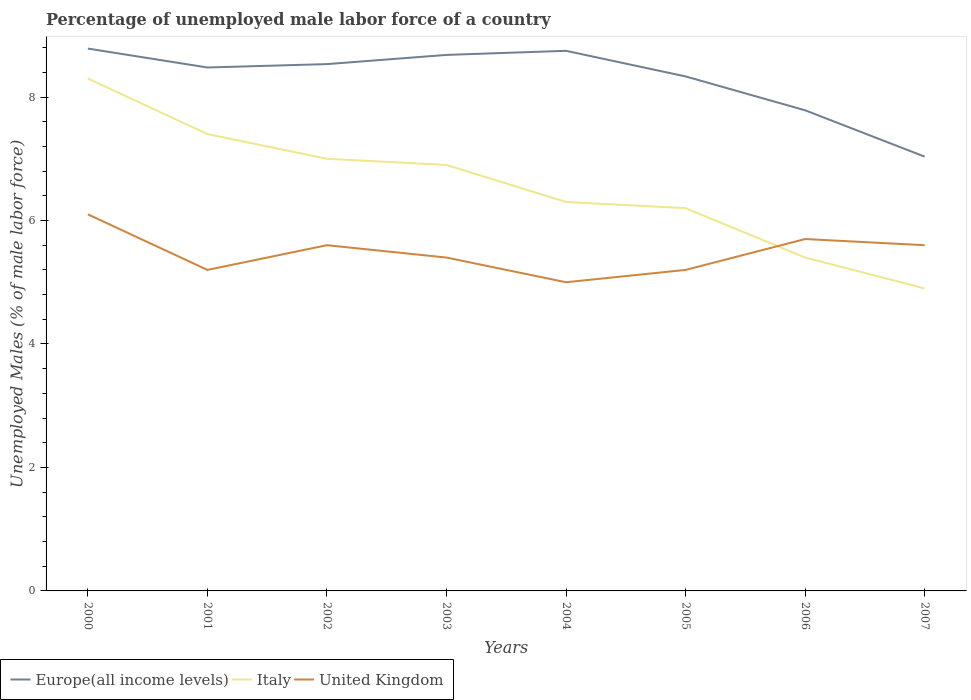What is the total percentage of unemployed male labor force in Europe(all income levels) in the graph?
Your response must be concise. 0.75. What is the difference between the highest and the second highest percentage of unemployed male labor force in Italy?
Your response must be concise. 3.4. How many years are there in the graph?
Offer a terse response. 8. What is the difference between two consecutive major ticks on the Y-axis?
Keep it short and to the point. 2. Does the graph contain any zero values?
Ensure brevity in your answer.  No. What is the title of the graph?
Give a very brief answer. Percentage of unemployed male labor force of a country. What is the label or title of the X-axis?
Ensure brevity in your answer.  Years. What is the label or title of the Y-axis?
Offer a very short reply. Unemployed Males (% of male labor force). What is the Unemployed Males (% of male labor force) in Europe(all income levels) in 2000?
Keep it short and to the point. 8.79. What is the Unemployed Males (% of male labor force) of Italy in 2000?
Your response must be concise. 8.3. What is the Unemployed Males (% of male labor force) of United Kingdom in 2000?
Make the answer very short. 6.1. What is the Unemployed Males (% of male labor force) in Europe(all income levels) in 2001?
Give a very brief answer. 8.48. What is the Unemployed Males (% of male labor force) of Italy in 2001?
Provide a short and direct response. 7.4. What is the Unemployed Males (% of male labor force) in United Kingdom in 2001?
Keep it short and to the point. 5.2. What is the Unemployed Males (% of male labor force) of Europe(all income levels) in 2002?
Offer a very short reply. 8.53. What is the Unemployed Males (% of male labor force) in Italy in 2002?
Your answer should be very brief. 7. What is the Unemployed Males (% of male labor force) in United Kingdom in 2002?
Offer a terse response. 5.6. What is the Unemployed Males (% of male labor force) in Europe(all income levels) in 2003?
Offer a terse response. 8.68. What is the Unemployed Males (% of male labor force) of Italy in 2003?
Ensure brevity in your answer.  6.9. What is the Unemployed Males (% of male labor force) in United Kingdom in 2003?
Offer a very short reply. 5.4. What is the Unemployed Males (% of male labor force) of Europe(all income levels) in 2004?
Offer a very short reply. 8.75. What is the Unemployed Males (% of male labor force) in Italy in 2004?
Offer a terse response. 6.3. What is the Unemployed Males (% of male labor force) of United Kingdom in 2004?
Ensure brevity in your answer.  5. What is the Unemployed Males (% of male labor force) in Europe(all income levels) in 2005?
Give a very brief answer. 8.33. What is the Unemployed Males (% of male labor force) in Italy in 2005?
Provide a succinct answer. 6.2. What is the Unemployed Males (% of male labor force) of United Kingdom in 2005?
Ensure brevity in your answer.  5.2. What is the Unemployed Males (% of male labor force) in Europe(all income levels) in 2006?
Provide a succinct answer. 7.79. What is the Unemployed Males (% of male labor force) of Italy in 2006?
Your answer should be very brief. 5.4. What is the Unemployed Males (% of male labor force) in United Kingdom in 2006?
Make the answer very short. 5.7. What is the Unemployed Males (% of male labor force) of Europe(all income levels) in 2007?
Make the answer very short. 7.03. What is the Unemployed Males (% of male labor force) of Italy in 2007?
Ensure brevity in your answer.  4.9. What is the Unemployed Males (% of male labor force) in United Kingdom in 2007?
Keep it short and to the point. 5.6. Across all years, what is the maximum Unemployed Males (% of male labor force) of Europe(all income levels)?
Offer a terse response. 8.79. Across all years, what is the maximum Unemployed Males (% of male labor force) in Italy?
Offer a terse response. 8.3. Across all years, what is the maximum Unemployed Males (% of male labor force) of United Kingdom?
Your answer should be compact. 6.1. Across all years, what is the minimum Unemployed Males (% of male labor force) in Europe(all income levels)?
Keep it short and to the point. 7.03. Across all years, what is the minimum Unemployed Males (% of male labor force) in Italy?
Make the answer very short. 4.9. What is the total Unemployed Males (% of male labor force) in Europe(all income levels) in the graph?
Make the answer very short. 66.38. What is the total Unemployed Males (% of male labor force) of Italy in the graph?
Offer a very short reply. 52.4. What is the total Unemployed Males (% of male labor force) of United Kingdom in the graph?
Offer a very short reply. 43.8. What is the difference between the Unemployed Males (% of male labor force) in Europe(all income levels) in 2000 and that in 2001?
Your answer should be compact. 0.31. What is the difference between the Unemployed Males (% of male labor force) of Italy in 2000 and that in 2001?
Ensure brevity in your answer.  0.9. What is the difference between the Unemployed Males (% of male labor force) of Europe(all income levels) in 2000 and that in 2002?
Keep it short and to the point. 0.25. What is the difference between the Unemployed Males (% of male labor force) of Italy in 2000 and that in 2002?
Give a very brief answer. 1.3. What is the difference between the Unemployed Males (% of male labor force) of Europe(all income levels) in 2000 and that in 2003?
Keep it short and to the point. 0.1. What is the difference between the Unemployed Males (% of male labor force) of Italy in 2000 and that in 2003?
Offer a terse response. 1.4. What is the difference between the Unemployed Males (% of male labor force) in Europe(all income levels) in 2000 and that in 2004?
Ensure brevity in your answer.  0.04. What is the difference between the Unemployed Males (% of male labor force) of United Kingdom in 2000 and that in 2004?
Your answer should be very brief. 1.1. What is the difference between the Unemployed Males (% of male labor force) of Europe(all income levels) in 2000 and that in 2005?
Make the answer very short. 0.45. What is the difference between the Unemployed Males (% of male labor force) of Italy in 2000 and that in 2005?
Give a very brief answer. 2.1. What is the difference between the Unemployed Males (% of male labor force) of United Kingdom in 2000 and that in 2005?
Give a very brief answer. 0.9. What is the difference between the Unemployed Males (% of male labor force) in Europe(all income levels) in 2000 and that in 2006?
Provide a succinct answer. 1. What is the difference between the Unemployed Males (% of male labor force) in Europe(all income levels) in 2000 and that in 2007?
Give a very brief answer. 1.75. What is the difference between the Unemployed Males (% of male labor force) of United Kingdom in 2000 and that in 2007?
Your response must be concise. 0.5. What is the difference between the Unemployed Males (% of male labor force) of Europe(all income levels) in 2001 and that in 2002?
Your response must be concise. -0.05. What is the difference between the Unemployed Males (% of male labor force) of Italy in 2001 and that in 2002?
Give a very brief answer. 0.4. What is the difference between the Unemployed Males (% of male labor force) of Europe(all income levels) in 2001 and that in 2003?
Your answer should be very brief. -0.2. What is the difference between the Unemployed Males (% of male labor force) in United Kingdom in 2001 and that in 2003?
Keep it short and to the point. -0.2. What is the difference between the Unemployed Males (% of male labor force) of Europe(all income levels) in 2001 and that in 2004?
Your response must be concise. -0.27. What is the difference between the Unemployed Males (% of male labor force) in United Kingdom in 2001 and that in 2004?
Offer a terse response. 0.2. What is the difference between the Unemployed Males (% of male labor force) of Europe(all income levels) in 2001 and that in 2005?
Ensure brevity in your answer.  0.14. What is the difference between the Unemployed Males (% of male labor force) in Italy in 2001 and that in 2005?
Provide a short and direct response. 1.2. What is the difference between the Unemployed Males (% of male labor force) in Europe(all income levels) in 2001 and that in 2006?
Provide a succinct answer. 0.69. What is the difference between the Unemployed Males (% of male labor force) in Italy in 2001 and that in 2006?
Offer a terse response. 2. What is the difference between the Unemployed Males (% of male labor force) of Europe(all income levels) in 2001 and that in 2007?
Give a very brief answer. 1.44. What is the difference between the Unemployed Males (% of male labor force) in Italy in 2001 and that in 2007?
Your answer should be very brief. 2.5. What is the difference between the Unemployed Males (% of male labor force) in United Kingdom in 2001 and that in 2007?
Offer a very short reply. -0.4. What is the difference between the Unemployed Males (% of male labor force) in Europe(all income levels) in 2002 and that in 2003?
Your answer should be very brief. -0.15. What is the difference between the Unemployed Males (% of male labor force) in Italy in 2002 and that in 2003?
Offer a very short reply. 0.1. What is the difference between the Unemployed Males (% of male labor force) of Europe(all income levels) in 2002 and that in 2004?
Keep it short and to the point. -0.22. What is the difference between the Unemployed Males (% of male labor force) of Italy in 2002 and that in 2004?
Your response must be concise. 0.7. What is the difference between the Unemployed Males (% of male labor force) of United Kingdom in 2002 and that in 2004?
Your response must be concise. 0.6. What is the difference between the Unemployed Males (% of male labor force) in Europe(all income levels) in 2002 and that in 2005?
Keep it short and to the point. 0.2. What is the difference between the Unemployed Males (% of male labor force) in Italy in 2002 and that in 2005?
Your response must be concise. 0.8. What is the difference between the Unemployed Males (% of male labor force) in Europe(all income levels) in 2002 and that in 2006?
Ensure brevity in your answer.  0.75. What is the difference between the Unemployed Males (% of male labor force) of United Kingdom in 2002 and that in 2006?
Give a very brief answer. -0.1. What is the difference between the Unemployed Males (% of male labor force) of Europe(all income levels) in 2002 and that in 2007?
Your response must be concise. 1.5. What is the difference between the Unemployed Males (% of male labor force) in United Kingdom in 2002 and that in 2007?
Offer a terse response. 0. What is the difference between the Unemployed Males (% of male labor force) of Europe(all income levels) in 2003 and that in 2004?
Ensure brevity in your answer.  -0.07. What is the difference between the Unemployed Males (% of male labor force) in Europe(all income levels) in 2003 and that in 2005?
Offer a very short reply. 0.35. What is the difference between the Unemployed Males (% of male labor force) of United Kingdom in 2003 and that in 2005?
Your answer should be very brief. 0.2. What is the difference between the Unemployed Males (% of male labor force) of Europe(all income levels) in 2003 and that in 2006?
Make the answer very short. 0.9. What is the difference between the Unemployed Males (% of male labor force) of Europe(all income levels) in 2003 and that in 2007?
Provide a short and direct response. 1.65. What is the difference between the Unemployed Males (% of male labor force) in Italy in 2003 and that in 2007?
Offer a terse response. 2. What is the difference between the Unemployed Males (% of male labor force) in United Kingdom in 2003 and that in 2007?
Make the answer very short. -0.2. What is the difference between the Unemployed Males (% of male labor force) of Europe(all income levels) in 2004 and that in 2005?
Your answer should be compact. 0.41. What is the difference between the Unemployed Males (% of male labor force) in Italy in 2004 and that in 2005?
Provide a short and direct response. 0.1. What is the difference between the Unemployed Males (% of male labor force) in United Kingdom in 2004 and that in 2005?
Provide a short and direct response. -0.2. What is the difference between the Unemployed Males (% of male labor force) in Europe(all income levels) in 2004 and that in 2006?
Your response must be concise. 0.96. What is the difference between the Unemployed Males (% of male labor force) of Italy in 2004 and that in 2006?
Your answer should be compact. 0.9. What is the difference between the Unemployed Males (% of male labor force) in Europe(all income levels) in 2004 and that in 2007?
Make the answer very short. 1.71. What is the difference between the Unemployed Males (% of male labor force) of Europe(all income levels) in 2005 and that in 2006?
Ensure brevity in your answer.  0.55. What is the difference between the Unemployed Males (% of male labor force) of Italy in 2005 and that in 2006?
Make the answer very short. 0.8. What is the difference between the Unemployed Males (% of male labor force) in United Kingdom in 2005 and that in 2006?
Your answer should be compact. -0.5. What is the difference between the Unemployed Males (% of male labor force) in Europe(all income levels) in 2005 and that in 2007?
Offer a terse response. 1.3. What is the difference between the Unemployed Males (% of male labor force) of Italy in 2005 and that in 2007?
Provide a short and direct response. 1.3. What is the difference between the Unemployed Males (% of male labor force) of Europe(all income levels) in 2006 and that in 2007?
Ensure brevity in your answer.  0.75. What is the difference between the Unemployed Males (% of male labor force) in Italy in 2006 and that in 2007?
Your answer should be compact. 0.5. What is the difference between the Unemployed Males (% of male labor force) of Europe(all income levels) in 2000 and the Unemployed Males (% of male labor force) of Italy in 2001?
Provide a succinct answer. 1.39. What is the difference between the Unemployed Males (% of male labor force) in Europe(all income levels) in 2000 and the Unemployed Males (% of male labor force) in United Kingdom in 2001?
Provide a succinct answer. 3.59. What is the difference between the Unemployed Males (% of male labor force) of Europe(all income levels) in 2000 and the Unemployed Males (% of male labor force) of Italy in 2002?
Make the answer very short. 1.79. What is the difference between the Unemployed Males (% of male labor force) of Europe(all income levels) in 2000 and the Unemployed Males (% of male labor force) of United Kingdom in 2002?
Offer a terse response. 3.19. What is the difference between the Unemployed Males (% of male labor force) in Italy in 2000 and the Unemployed Males (% of male labor force) in United Kingdom in 2002?
Keep it short and to the point. 2.7. What is the difference between the Unemployed Males (% of male labor force) of Europe(all income levels) in 2000 and the Unemployed Males (% of male labor force) of Italy in 2003?
Your response must be concise. 1.89. What is the difference between the Unemployed Males (% of male labor force) of Europe(all income levels) in 2000 and the Unemployed Males (% of male labor force) of United Kingdom in 2003?
Offer a very short reply. 3.39. What is the difference between the Unemployed Males (% of male labor force) in Italy in 2000 and the Unemployed Males (% of male labor force) in United Kingdom in 2003?
Keep it short and to the point. 2.9. What is the difference between the Unemployed Males (% of male labor force) in Europe(all income levels) in 2000 and the Unemployed Males (% of male labor force) in Italy in 2004?
Your answer should be compact. 2.49. What is the difference between the Unemployed Males (% of male labor force) of Europe(all income levels) in 2000 and the Unemployed Males (% of male labor force) of United Kingdom in 2004?
Ensure brevity in your answer.  3.79. What is the difference between the Unemployed Males (% of male labor force) of Europe(all income levels) in 2000 and the Unemployed Males (% of male labor force) of Italy in 2005?
Your response must be concise. 2.59. What is the difference between the Unemployed Males (% of male labor force) in Europe(all income levels) in 2000 and the Unemployed Males (% of male labor force) in United Kingdom in 2005?
Your response must be concise. 3.59. What is the difference between the Unemployed Males (% of male labor force) of Europe(all income levels) in 2000 and the Unemployed Males (% of male labor force) of Italy in 2006?
Keep it short and to the point. 3.39. What is the difference between the Unemployed Males (% of male labor force) of Europe(all income levels) in 2000 and the Unemployed Males (% of male labor force) of United Kingdom in 2006?
Make the answer very short. 3.09. What is the difference between the Unemployed Males (% of male labor force) of Italy in 2000 and the Unemployed Males (% of male labor force) of United Kingdom in 2006?
Provide a succinct answer. 2.6. What is the difference between the Unemployed Males (% of male labor force) of Europe(all income levels) in 2000 and the Unemployed Males (% of male labor force) of Italy in 2007?
Ensure brevity in your answer.  3.89. What is the difference between the Unemployed Males (% of male labor force) in Europe(all income levels) in 2000 and the Unemployed Males (% of male labor force) in United Kingdom in 2007?
Give a very brief answer. 3.19. What is the difference between the Unemployed Males (% of male labor force) in Europe(all income levels) in 2001 and the Unemployed Males (% of male labor force) in Italy in 2002?
Offer a very short reply. 1.48. What is the difference between the Unemployed Males (% of male labor force) in Europe(all income levels) in 2001 and the Unemployed Males (% of male labor force) in United Kingdom in 2002?
Give a very brief answer. 2.88. What is the difference between the Unemployed Males (% of male labor force) of Italy in 2001 and the Unemployed Males (% of male labor force) of United Kingdom in 2002?
Ensure brevity in your answer.  1.8. What is the difference between the Unemployed Males (% of male labor force) of Europe(all income levels) in 2001 and the Unemployed Males (% of male labor force) of Italy in 2003?
Ensure brevity in your answer.  1.58. What is the difference between the Unemployed Males (% of male labor force) in Europe(all income levels) in 2001 and the Unemployed Males (% of male labor force) in United Kingdom in 2003?
Provide a succinct answer. 3.08. What is the difference between the Unemployed Males (% of male labor force) of Italy in 2001 and the Unemployed Males (% of male labor force) of United Kingdom in 2003?
Offer a terse response. 2. What is the difference between the Unemployed Males (% of male labor force) in Europe(all income levels) in 2001 and the Unemployed Males (% of male labor force) in Italy in 2004?
Your response must be concise. 2.18. What is the difference between the Unemployed Males (% of male labor force) of Europe(all income levels) in 2001 and the Unemployed Males (% of male labor force) of United Kingdom in 2004?
Offer a terse response. 3.48. What is the difference between the Unemployed Males (% of male labor force) in Europe(all income levels) in 2001 and the Unemployed Males (% of male labor force) in Italy in 2005?
Keep it short and to the point. 2.28. What is the difference between the Unemployed Males (% of male labor force) of Europe(all income levels) in 2001 and the Unemployed Males (% of male labor force) of United Kingdom in 2005?
Ensure brevity in your answer.  3.28. What is the difference between the Unemployed Males (% of male labor force) in Europe(all income levels) in 2001 and the Unemployed Males (% of male labor force) in Italy in 2006?
Your answer should be very brief. 3.08. What is the difference between the Unemployed Males (% of male labor force) in Europe(all income levels) in 2001 and the Unemployed Males (% of male labor force) in United Kingdom in 2006?
Your answer should be very brief. 2.78. What is the difference between the Unemployed Males (% of male labor force) of Europe(all income levels) in 2001 and the Unemployed Males (% of male labor force) of Italy in 2007?
Make the answer very short. 3.58. What is the difference between the Unemployed Males (% of male labor force) in Europe(all income levels) in 2001 and the Unemployed Males (% of male labor force) in United Kingdom in 2007?
Offer a terse response. 2.88. What is the difference between the Unemployed Males (% of male labor force) in Europe(all income levels) in 2002 and the Unemployed Males (% of male labor force) in Italy in 2003?
Provide a short and direct response. 1.63. What is the difference between the Unemployed Males (% of male labor force) of Europe(all income levels) in 2002 and the Unemployed Males (% of male labor force) of United Kingdom in 2003?
Make the answer very short. 3.13. What is the difference between the Unemployed Males (% of male labor force) in Italy in 2002 and the Unemployed Males (% of male labor force) in United Kingdom in 2003?
Give a very brief answer. 1.6. What is the difference between the Unemployed Males (% of male labor force) of Europe(all income levels) in 2002 and the Unemployed Males (% of male labor force) of Italy in 2004?
Keep it short and to the point. 2.23. What is the difference between the Unemployed Males (% of male labor force) in Europe(all income levels) in 2002 and the Unemployed Males (% of male labor force) in United Kingdom in 2004?
Ensure brevity in your answer.  3.53. What is the difference between the Unemployed Males (% of male labor force) in Europe(all income levels) in 2002 and the Unemployed Males (% of male labor force) in Italy in 2005?
Offer a very short reply. 2.33. What is the difference between the Unemployed Males (% of male labor force) in Europe(all income levels) in 2002 and the Unemployed Males (% of male labor force) in United Kingdom in 2005?
Keep it short and to the point. 3.33. What is the difference between the Unemployed Males (% of male labor force) in Italy in 2002 and the Unemployed Males (% of male labor force) in United Kingdom in 2005?
Ensure brevity in your answer.  1.8. What is the difference between the Unemployed Males (% of male labor force) of Europe(all income levels) in 2002 and the Unemployed Males (% of male labor force) of Italy in 2006?
Give a very brief answer. 3.13. What is the difference between the Unemployed Males (% of male labor force) in Europe(all income levels) in 2002 and the Unemployed Males (% of male labor force) in United Kingdom in 2006?
Give a very brief answer. 2.83. What is the difference between the Unemployed Males (% of male labor force) in Europe(all income levels) in 2002 and the Unemployed Males (% of male labor force) in Italy in 2007?
Offer a terse response. 3.63. What is the difference between the Unemployed Males (% of male labor force) of Europe(all income levels) in 2002 and the Unemployed Males (% of male labor force) of United Kingdom in 2007?
Your answer should be very brief. 2.93. What is the difference between the Unemployed Males (% of male labor force) of Italy in 2002 and the Unemployed Males (% of male labor force) of United Kingdom in 2007?
Your answer should be compact. 1.4. What is the difference between the Unemployed Males (% of male labor force) of Europe(all income levels) in 2003 and the Unemployed Males (% of male labor force) of Italy in 2004?
Your response must be concise. 2.38. What is the difference between the Unemployed Males (% of male labor force) of Europe(all income levels) in 2003 and the Unemployed Males (% of male labor force) of United Kingdom in 2004?
Keep it short and to the point. 3.68. What is the difference between the Unemployed Males (% of male labor force) in Italy in 2003 and the Unemployed Males (% of male labor force) in United Kingdom in 2004?
Ensure brevity in your answer.  1.9. What is the difference between the Unemployed Males (% of male labor force) in Europe(all income levels) in 2003 and the Unemployed Males (% of male labor force) in Italy in 2005?
Provide a short and direct response. 2.48. What is the difference between the Unemployed Males (% of male labor force) of Europe(all income levels) in 2003 and the Unemployed Males (% of male labor force) of United Kingdom in 2005?
Make the answer very short. 3.48. What is the difference between the Unemployed Males (% of male labor force) of Europe(all income levels) in 2003 and the Unemployed Males (% of male labor force) of Italy in 2006?
Provide a succinct answer. 3.28. What is the difference between the Unemployed Males (% of male labor force) of Europe(all income levels) in 2003 and the Unemployed Males (% of male labor force) of United Kingdom in 2006?
Provide a short and direct response. 2.98. What is the difference between the Unemployed Males (% of male labor force) in Italy in 2003 and the Unemployed Males (% of male labor force) in United Kingdom in 2006?
Provide a succinct answer. 1.2. What is the difference between the Unemployed Males (% of male labor force) in Europe(all income levels) in 2003 and the Unemployed Males (% of male labor force) in Italy in 2007?
Offer a very short reply. 3.78. What is the difference between the Unemployed Males (% of male labor force) of Europe(all income levels) in 2003 and the Unemployed Males (% of male labor force) of United Kingdom in 2007?
Your answer should be compact. 3.08. What is the difference between the Unemployed Males (% of male labor force) of Italy in 2003 and the Unemployed Males (% of male labor force) of United Kingdom in 2007?
Give a very brief answer. 1.3. What is the difference between the Unemployed Males (% of male labor force) of Europe(all income levels) in 2004 and the Unemployed Males (% of male labor force) of Italy in 2005?
Provide a succinct answer. 2.55. What is the difference between the Unemployed Males (% of male labor force) in Europe(all income levels) in 2004 and the Unemployed Males (% of male labor force) in United Kingdom in 2005?
Ensure brevity in your answer.  3.55. What is the difference between the Unemployed Males (% of male labor force) of Italy in 2004 and the Unemployed Males (% of male labor force) of United Kingdom in 2005?
Offer a very short reply. 1.1. What is the difference between the Unemployed Males (% of male labor force) in Europe(all income levels) in 2004 and the Unemployed Males (% of male labor force) in Italy in 2006?
Your response must be concise. 3.35. What is the difference between the Unemployed Males (% of male labor force) in Europe(all income levels) in 2004 and the Unemployed Males (% of male labor force) in United Kingdom in 2006?
Offer a terse response. 3.05. What is the difference between the Unemployed Males (% of male labor force) in Europe(all income levels) in 2004 and the Unemployed Males (% of male labor force) in Italy in 2007?
Make the answer very short. 3.85. What is the difference between the Unemployed Males (% of male labor force) of Europe(all income levels) in 2004 and the Unemployed Males (% of male labor force) of United Kingdom in 2007?
Keep it short and to the point. 3.15. What is the difference between the Unemployed Males (% of male labor force) of Italy in 2004 and the Unemployed Males (% of male labor force) of United Kingdom in 2007?
Keep it short and to the point. 0.7. What is the difference between the Unemployed Males (% of male labor force) in Europe(all income levels) in 2005 and the Unemployed Males (% of male labor force) in Italy in 2006?
Ensure brevity in your answer.  2.93. What is the difference between the Unemployed Males (% of male labor force) of Europe(all income levels) in 2005 and the Unemployed Males (% of male labor force) of United Kingdom in 2006?
Make the answer very short. 2.63. What is the difference between the Unemployed Males (% of male labor force) of Europe(all income levels) in 2005 and the Unemployed Males (% of male labor force) of Italy in 2007?
Your answer should be very brief. 3.43. What is the difference between the Unemployed Males (% of male labor force) of Europe(all income levels) in 2005 and the Unemployed Males (% of male labor force) of United Kingdom in 2007?
Provide a succinct answer. 2.73. What is the difference between the Unemployed Males (% of male labor force) in Europe(all income levels) in 2006 and the Unemployed Males (% of male labor force) in Italy in 2007?
Offer a terse response. 2.89. What is the difference between the Unemployed Males (% of male labor force) of Europe(all income levels) in 2006 and the Unemployed Males (% of male labor force) of United Kingdom in 2007?
Your answer should be compact. 2.19. What is the difference between the Unemployed Males (% of male labor force) of Italy in 2006 and the Unemployed Males (% of male labor force) of United Kingdom in 2007?
Your response must be concise. -0.2. What is the average Unemployed Males (% of male labor force) of Europe(all income levels) per year?
Provide a succinct answer. 8.3. What is the average Unemployed Males (% of male labor force) in Italy per year?
Provide a short and direct response. 6.55. What is the average Unemployed Males (% of male labor force) in United Kingdom per year?
Ensure brevity in your answer.  5.47. In the year 2000, what is the difference between the Unemployed Males (% of male labor force) in Europe(all income levels) and Unemployed Males (% of male labor force) in Italy?
Your answer should be very brief. 0.49. In the year 2000, what is the difference between the Unemployed Males (% of male labor force) of Europe(all income levels) and Unemployed Males (% of male labor force) of United Kingdom?
Provide a short and direct response. 2.69. In the year 2000, what is the difference between the Unemployed Males (% of male labor force) in Italy and Unemployed Males (% of male labor force) in United Kingdom?
Provide a succinct answer. 2.2. In the year 2001, what is the difference between the Unemployed Males (% of male labor force) of Europe(all income levels) and Unemployed Males (% of male labor force) of Italy?
Give a very brief answer. 1.08. In the year 2001, what is the difference between the Unemployed Males (% of male labor force) of Europe(all income levels) and Unemployed Males (% of male labor force) of United Kingdom?
Make the answer very short. 3.28. In the year 2001, what is the difference between the Unemployed Males (% of male labor force) in Italy and Unemployed Males (% of male labor force) in United Kingdom?
Offer a very short reply. 2.2. In the year 2002, what is the difference between the Unemployed Males (% of male labor force) in Europe(all income levels) and Unemployed Males (% of male labor force) in Italy?
Your answer should be very brief. 1.53. In the year 2002, what is the difference between the Unemployed Males (% of male labor force) in Europe(all income levels) and Unemployed Males (% of male labor force) in United Kingdom?
Offer a terse response. 2.93. In the year 2002, what is the difference between the Unemployed Males (% of male labor force) of Italy and Unemployed Males (% of male labor force) of United Kingdom?
Provide a succinct answer. 1.4. In the year 2003, what is the difference between the Unemployed Males (% of male labor force) in Europe(all income levels) and Unemployed Males (% of male labor force) in Italy?
Keep it short and to the point. 1.78. In the year 2003, what is the difference between the Unemployed Males (% of male labor force) in Europe(all income levels) and Unemployed Males (% of male labor force) in United Kingdom?
Provide a short and direct response. 3.28. In the year 2004, what is the difference between the Unemployed Males (% of male labor force) in Europe(all income levels) and Unemployed Males (% of male labor force) in Italy?
Your answer should be compact. 2.45. In the year 2004, what is the difference between the Unemployed Males (% of male labor force) of Europe(all income levels) and Unemployed Males (% of male labor force) of United Kingdom?
Give a very brief answer. 3.75. In the year 2005, what is the difference between the Unemployed Males (% of male labor force) in Europe(all income levels) and Unemployed Males (% of male labor force) in Italy?
Offer a terse response. 2.13. In the year 2005, what is the difference between the Unemployed Males (% of male labor force) in Europe(all income levels) and Unemployed Males (% of male labor force) in United Kingdom?
Provide a succinct answer. 3.13. In the year 2006, what is the difference between the Unemployed Males (% of male labor force) in Europe(all income levels) and Unemployed Males (% of male labor force) in Italy?
Ensure brevity in your answer.  2.39. In the year 2006, what is the difference between the Unemployed Males (% of male labor force) of Europe(all income levels) and Unemployed Males (% of male labor force) of United Kingdom?
Provide a succinct answer. 2.09. In the year 2007, what is the difference between the Unemployed Males (% of male labor force) of Europe(all income levels) and Unemployed Males (% of male labor force) of Italy?
Provide a succinct answer. 2.13. In the year 2007, what is the difference between the Unemployed Males (% of male labor force) of Europe(all income levels) and Unemployed Males (% of male labor force) of United Kingdom?
Provide a short and direct response. 1.43. What is the ratio of the Unemployed Males (% of male labor force) of Europe(all income levels) in 2000 to that in 2001?
Your response must be concise. 1.04. What is the ratio of the Unemployed Males (% of male labor force) of Italy in 2000 to that in 2001?
Make the answer very short. 1.12. What is the ratio of the Unemployed Males (% of male labor force) of United Kingdom in 2000 to that in 2001?
Provide a short and direct response. 1.17. What is the ratio of the Unemployed Males (% of male labor force) of Europe(all income levels) in 2000 to that in 2002?
Make the answer very short. 1.03. What is the ratio of the Unemployed Males (% of male labor force) of Italy in 2000 to that in 2002?
Your answer should be very brief. 1.19. What is the ratio of the Unemployed Males (% of male labor force) in United Kingdom in 2000 to that in 2002?
Offer a very short reply. 1.09. What is the ratio of the Unemployed Males (% of male labor force) in Europe(all income levels) in 2000 to that in 2003?
Provide a succinct answer. 1.01. What is the ratio of the Unemployed Males (% of male labor force) in Italy in 2000 to that in 2003?
Offer a very short reply. 1.2. What is the ratio of the Unemployed Males (% of male labor force) in United Kingdom in 2000 to that in 2003?
Your answer should be very brief. 1.13. What is the ratio of the Unemployed Males (% of male labor force) in Italy in 2000 to that in 2004?
Provide a succinct answer. 1.32. What is the ratio of the Unemployed Males (% of male labor force) of United Kingdom in 2000 to that in 2004?
Keep it short and to the point. 1.22. What is the ratio of the Unemployed Males (% of male labor force) of Europe(all income levels) in 2000 to that in 2005?
Your answer should be compact. 1.05. What is the ratio of the Unemployed Males (% of male labor force) of Italy in 2000 to that in 2005?
Your answer should be compact. 1.34. What is the ratio of the Unemployed Males (% of male labor force) of United Kingdom in 2000 to that in 2005?
Offer a terse response. 1.17. What is the ratio of the Unemployed Males (% of male labor force) of Europe(all income levels) in 2000 to that in 2006?
Your answer should be very brief. 1.13. What is the ratio of the Unemployed Males (% of male labor force) in Italy in 2000 to that in 2006?
Ensure brevity in your answer.  1.54. What is the ratio of the Unemployed Males (% of male labor force) in United Kingdom in 2000 to that in 2006?
Offer a very short reply. 1.07. What is the ratio of the Unemployed Males (% of male labor force) of Europe(all income levels) in 2000 to that in 2007?
Offer a very short reply. 1.25. What is the ratio of the Unemployed Males (% of male labor force) in Italy in 2000 to that in 2007?
Offer a terse response. 1.69. What is the ratio of the Unemployed Males (% of male labor force) of United Kingdom in 2000 to that in 2007?
Your answer should be compact. 1.09. What is the ratio of the Unemployed Males (% of male labor force) in Italy in 2001 to that in 2002?
Your answer should be compact. 1.06. What is the ratio of the Unemployed Males (% of male labor force) in United Kingdom in 2001 to that in 2002?
Provide a short and direct response. 0.93. What is the ratio of the Unemployed Males (% of male labor force) of Europe(all income levels) in 2001 to that in 2003?
Your answer should be compact. 0.98. What is the ratio of the Unemployed Males (% of male labor force) in Italy in 2001 to that in 2003?
Offer a terse response. 1.07. What is the ratio of the Unemployed Males (% of male labor force) of United Kingdom in 2001 to that in 2003?
Provide a succinct answer. 0.96. What is the ratio of the Unemployed Males (% of male labor force) in Europe(all income levels) in 2001 to that in 2004?
Offer a very short reply. 0.97. What is the ratio of the Unemployed Males (% of male labor force) of Italy in 2001 to that in 2004?
Your response must be concise. 1.17. What is the ratio of the Unemployed Males (% of male labor force) in Europe(all income levels) in 2001 to that in 2005?
Your answer should be very brief. 1.02. What is the ratio of the Unemployed Males (% of male labor force) in Italy in 2001 to that in 2005?
Offer a very short reply. 1.19. What is the ratio of the Unemployed Males (% of male labor force) of United Kingdom in 2001 to that in 2005?
Provide a succinct answer. 1. What is the ratio of the Unemployed Males (% of male labor force) of Europe(all income levels) in 2001 to that in 2006?
Your answer should be compact. 1.09. What is the ratio of the Unemployed Males (% of male labor force) of Italy in 2001 to that in 2006?
Provide a succinct answer. 1.37. What is the ratio of the Unemployed Males (% of male labor force) of United Kingdom in 2001 to that in 2006?
Your answer should be compact. 0.91. What is the ratio of the Unemployed Males (% of male labor force) in Europe(all income levels) in 2001 to that in 2007?
Ensure brevity in your answer.  1.21. What is the ratio of the Unemployed Males (% of male labor force) of Italy in 2001 to that in 2007?
Offer a terse response. 1.51. What is the ratio of the Unemployed Males (% of male labor force) of United Kingdom in 2001 to that in 2007?
Your answer should be compact. 0.93. What is the ratio of the Unemployed Males (% of male labor force) in Europe(all income levels) in 2002 to that in 2003?
Your response must be concise. 0.98. What is the ratio of the Unemployed Males (% of male labor force) in Italy in 2002 to that in 2003?
Your answer should be compact. 1.01. What is the ratio of the Unemployed Males (% of male labor force) of United Kingdom in 2002 to that in 2003?
Offer a very short reply. 1.04. What is the ratio of the Unemployed Males (% of male labor force) in Europe(all income levels) in 2002 to that in 2004?
Your answer should be very brief. 0.98. What is the ratio of the Unemployed Males (% of male labor force) of United Kingdom in 2002 to that in 2004?
Your answer should be compact. 1.12. What is the ratio of the Unemployed Males (% of male labor force) in Europe(all income levels) in 2002 to that in 2005?
Keep it short and to the point. 1.02. What is the ratio of the Unemployed Males (% of male labor force) in Italy in 2002 to that in 2005?
Ensure brevity in your answer.  1.13. What is the ratio of the Unemployed Males (% of male labor force) of Europe(all income levels) in 2002 to that in 2006?
Keep it short and to the point. 1.1. What is the ratio of the Unemployed Males (% of male labor force) in Italy in 2002 to that in 2006?
Offer a very short reply. 1.3. What is the ratio of the Unemployed Males (% of male labor force) in United Kingdom in 2002 to that in 2006?
Keep it short and to the point. 0.98. What is the ratio of the Unemployed Males (% of male labor force) in Europe(all income levels) in 2002 to that in 2007?
Your answer should be very brief. 1.21. What is the ratio of the Unemployed Males (% of male labor force) of Italy in 2002 to that in 2007?
Ensure brevity in your answer.  1.43. What is the ratio of the Unemployed Males (% of male labor force) of Europe(all income levels) in 2003 to that in 2004?
Offer a very short reply. 0.99. What is the ratio of the Unemployed Males (% of male labor force) in Italy in 2003 to that in 2004?
Your answer should be compact. 1.1. What is the ratio of the Unemployed Males (% of male labor force) of Europe(all income levels) in 2003 to that in 2005?
Keep it short and to the point. 1.04. What is the ratio of the Unemployed Males (% of male labor force) of Italy in 2003 to that in 2005?
Provide a succinct answer. 1.11. What is the ratio of the Unemployed Males (% of male labor force) in Europe(all income levels) in 2003 to that in 2006?
Your response must be concise. 1.12. What is the ratio of the Unemployed Males (% of male labor force) in Italy in 2003 to that in 2006?
Your answer should be compact. 1.28. What is the ratio of the Unemployed Males (% of male labor force) in United Kingdom in 2003 to that in 2006?
Offer a terse response. 0.95. What is the ratio of the Unemployed Males (% of male labor force) in Europe(all income levels) in 2003 to that in 2007?
Give a very brief answer. 1.23. What is the ratio of the Unemployed Males (% of male labor force) of Italy in 2003 to that in 2007?
Make the answer very short. 1.41. What is the ratio of the Unemployed Males (% of male labor force) in United Kingdom in 2003 to that in 2007?
Offer a terse response. 0.96. What is the ratio of the Unemployed Males (% of male labor force) of Europe(all income levels) in 2004 to that in 2005?
Provide a succinct answer. 1.05. What is the ratio of the Unemployed Males (% of male labor force) of Italy in 2004 to that in 2005?
Ensure brevity in your answer.  1.02. What is the ratio of the Unemployed Males (% of male labor force) in United Kingdom in 2004 to that in 2005?
Offer a very short reply. 0.96. What is the ratio of the Unemployed Males (% of male labor force) of Europe(all income levels) in 2004 to that in 2006?
Make the answer very short. 1.12. What is the ratio of the Unemployed Males (% of male labor force) of United Kingdom in 2004 to that in 2006?
Your response must be concise. 0.88. What is the ratio of the Unemployed Males (% of male labor force) in Europe(all income levels) in 2004 to that in 2007?
Make the answer very short. 1.24. What is the ratio of the Unemployed Males (% of male labor force) in Italy in 2004 to that in 2007?
Make the answer very short. 1.29. What is the ratio of the Unemployed Males (% of male labor force) in United Kingdom in 2004 to that in 2007?
Keep it short and to the point. 0.89. What is the ratio of the Unemployed Males (% of male labor force) of Europe(all income levels) in 2005 to that in 2006?
Offer a terse response. 1.07. What is the ratio of the Unemployed Males (% of male labor force) of Italy in 2005 to that in 2006?
Provide a short and direct response. 1.15. What is the ratio of the Unemployed Males (% of male labor force) in United Kingdom in 2005 to that in 2006?
Provide a succinct answer. 0.91. What is the ratio of the Unemployed Males (% of male labor force) in Europe(all income levels) in 2005 to that in 2007?
Your answer should be very brief. 1.18. What is the ratio of the Unemployed Males (% of male labor force) in Italy in 2005 to that in 2007?
Ensure brevity in your answer.  1.27. What is the ratio of the Unemployed Males (% of male labor force) of Europe(all income levels) in 2006 to that in 2007?
Provide a short and direct response. 1.11. What is the ratio of the Unemployed Males (% of male labor force) of Italy in 2006 to that in 2007?
Your answer should be compact. 1.1. What is the ratio of the Unemployed Males (% of male labor force) of United Kingdom in 2006 to that in 2007?
Keep it short and to the point. 1.02. What is the difference between the highest and the second highest Unemployed Males (% of male labor force) in Europe(all income levels)?
Keep it short and to the point. 0.04. What is the difference between the highest and the second highest Unemployed Males (% of male labor force) of Italy?
Provide a succinct answer. 0.9. What is the difference between the highest and the second highest Unemployed Males (% of male labor force) in United Kingdom?
Your answer should be compact. 0.4. What is the difference between the highest and the lowest Unemployed Males (% of male labor force) of Europe(all income levels)?
Keep it short and to the point. 1.75. What is the difference between the highest and the lowest Unemployed Males (% of male labor force) of Italy?
Offer a very short reply. 3.4. 